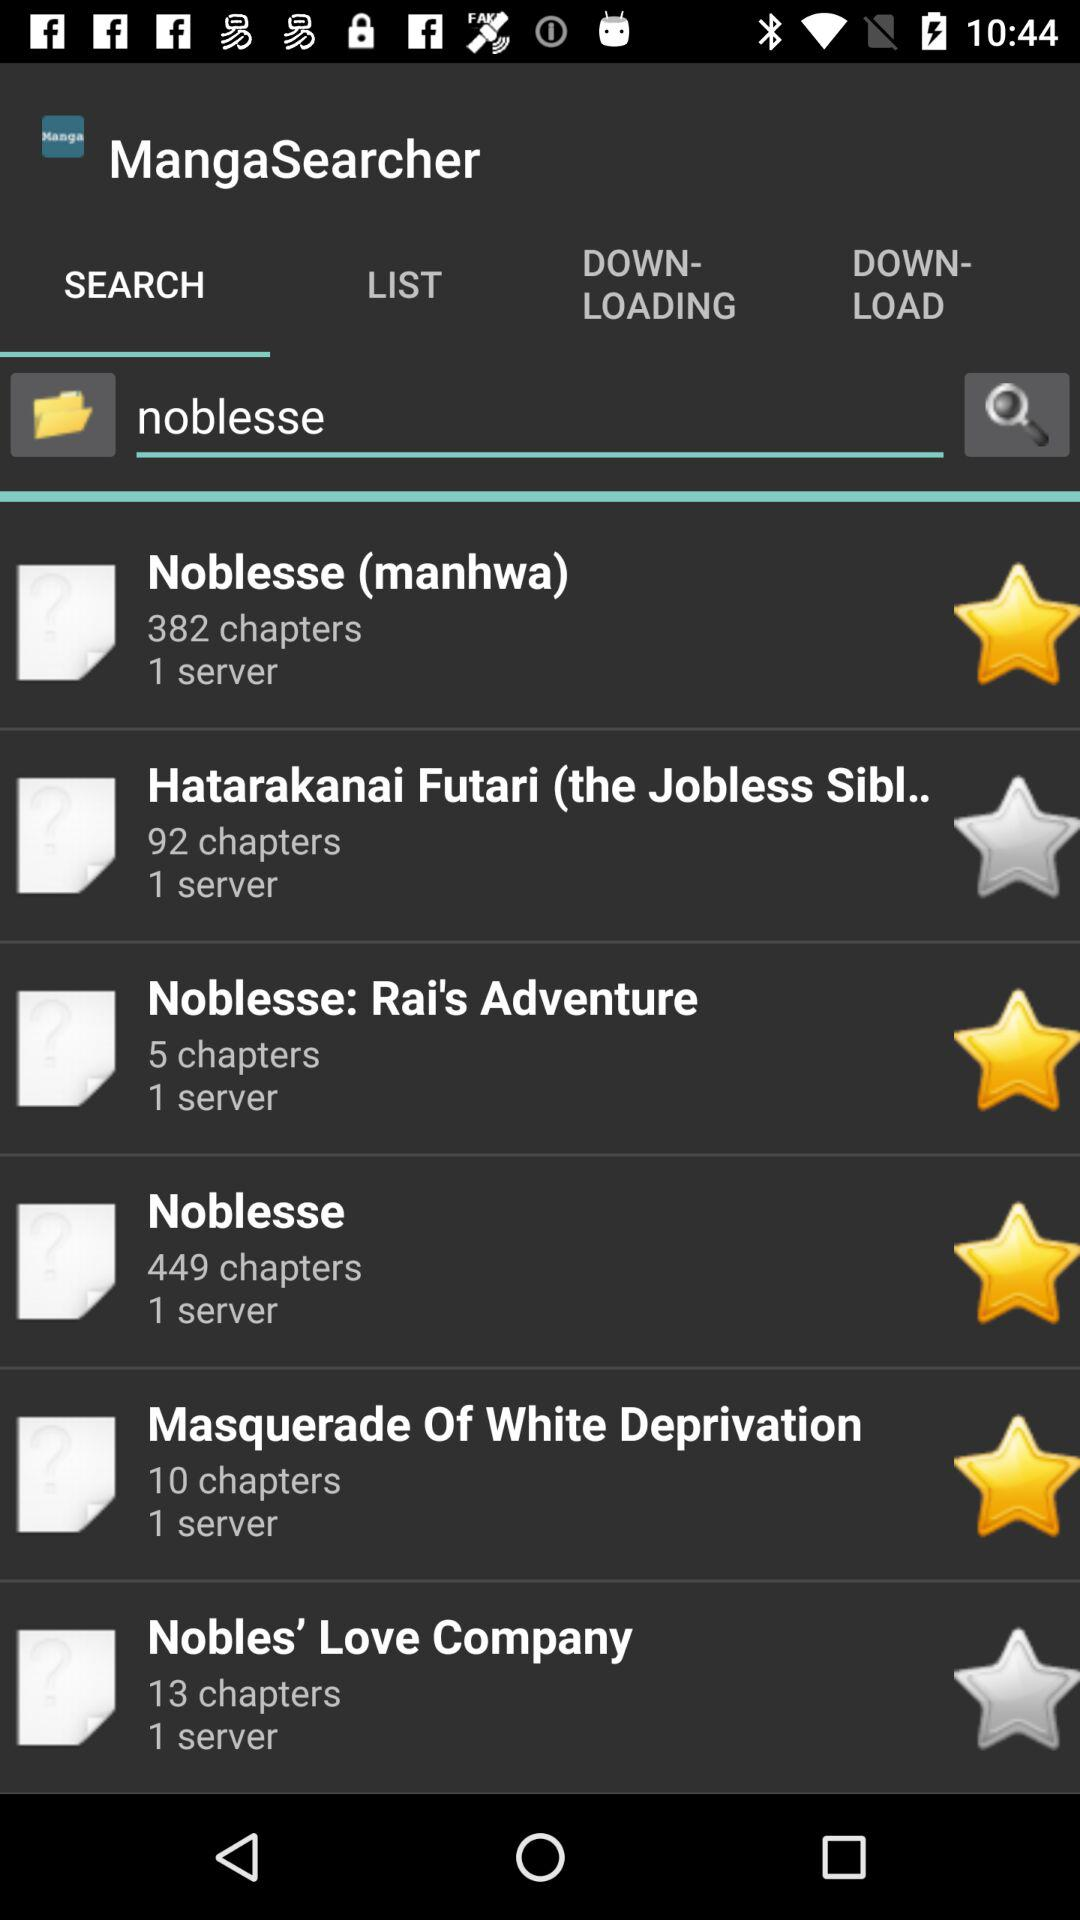How many chapters does the manga with the most chapters have?
Answer the question using a single word or phrase. 449 